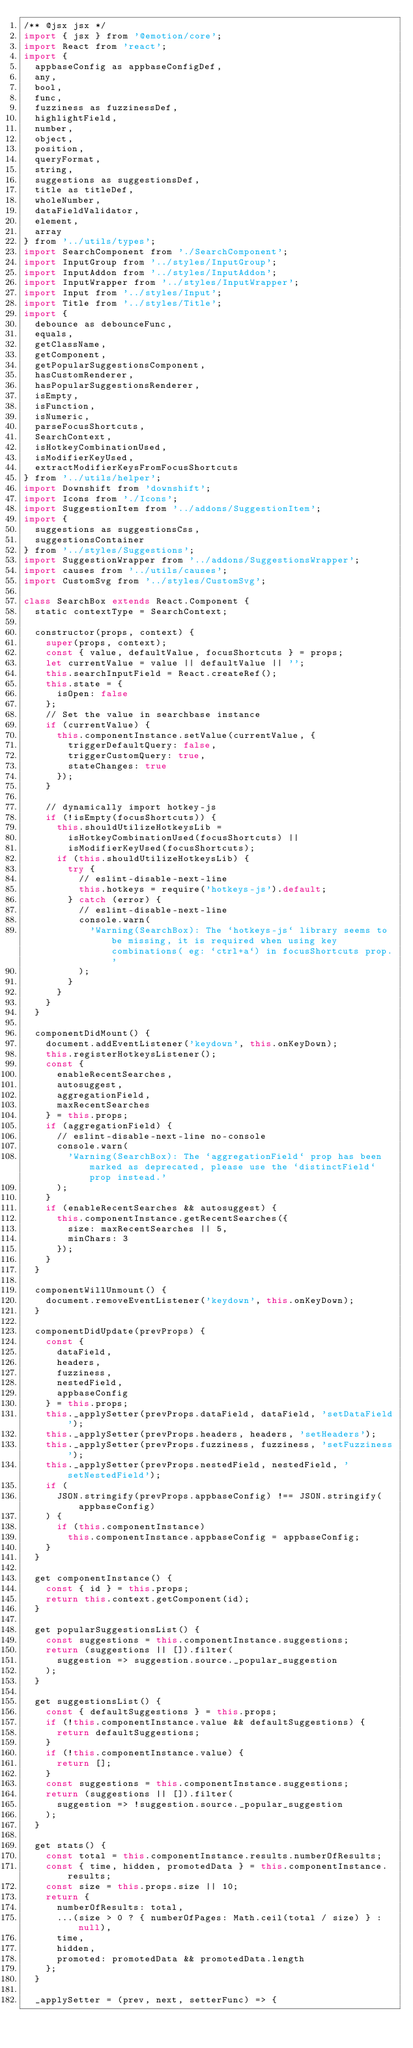<code> <loc_0><loc_0><loc_500><loc_500><_JavaScript_>/** @jsx jsx */
import { jsx } from '@emotion/core';
import React from 'react';
import {
  appbaseConfig as appbaseConfigDef,
  any,
  bool,
  func,
  fuzziness as fuzzinessDef,
  highlightField,
  number,
  object,
  position,
  queryFormat,
  string,
  suggestions as suggestionsDef,
  title as titleDef,
  wholeNumber,
  dataFieldValidator,
  element,
  array
} from '../utils/types';
import SearchComponent from './SearchComponent';
import InputGroup from '../styles/InputGroup';
import InputAddon from '../styles/InputAddon';
import InputWrapper from '../styles/InputWrapper';
import Input from '../styles/Input';
import Title from '../styles/Title';
import {
  debounce as debounceFunc,
  equals,
  getClassName,
  getComponent,
  getPopularSuggestionsComponent,
  hasCustomRenderer,
  hasPopularSuggestionsRenderer,
  isEmpty,
  isFunction,
  isNumeric,
  parseFocusShortcuts,
  SearchContext,
  isHotkeyCombinationUsed,
  isModifierKeyUsed,
  extractModifierKeysFromFocusShortcuts
} from '../utils/helper';
import Downshift from 'downshift';
import Icons from './Icons';
import SuggestionItem from '../addons/SuggestionItem';
import {
  suggestions as suggestionsCss,
  suggestionsContainer
} from '../styles/Suggestions';
import SuggestionWrapper from '../addons/SuggestionsWrapper';
import causes from '../utils/causes';
import CustomSvg from '../styles/CustomSvg';

class SearchBox extends React.Component {
  static contextType = SearchContext;

  constructor(props, context) {
    super(props, context);
    const { value, defaultValue, focusShortcuts } = props;
    let currentValue = value || defaultValue || '';
    this.searchInputField = React.createRef();
    this.state = {
      isOpen: false
    };
    // Set the value in searchbase instance
    if (currentValue) {
      this.componentInstance.setValue(currentValue, {
        triggerDefaultQuery: false,
        triggerCustomQuery: true,
        stateChanges: true
      });
    }

    // dynamically import hotkey-js
    if (!isEmpty(focusShortcuts)) {
      this.shouldUtilizeHotkeysLib =
        isHotkeyCombinationUsed(focusShortcuts) ||
        isModifierKeyUsed(focusShortcuts);
      if (this.shouldUtilizeHotkeysLib) {
        try {
          // eslint-disable-next-line
          this.hotkeys = require('hotkeys-js').default;
        } catch (error) {
          // eslint-disable-next-line
          console.warn(
            'Warning(SearchBox): The `hotkeys-js` library seems to be missing, it is required when using key combinations( eg: `ctrl+a`) in focusShortcuts prop.'
          );
        }
      }
    }
  }

  componentDidMount() {
    document.addEventListener('keydown', this.onKeyDown);
    this.registerHotkeysListener();
    const {
      enableRecentSearches,
      autosuggest,
      aggregationField,
      maxRecentSearches
    } = this.props;
    if (aggregationField) {
      // eslint-disable-next-line no-console
      console.warn(
        'Warning(SearchBox): The `aggregationField` prop has been marked as deprecated, please use the `distinctField` prop instead.'
      );
    }
    if (enableRecentSearches && autosuggest) {
      this.componentInstance.getRecentSearches({
        size: maxRecentSearches || 5,
        minChars: 3
      });
    }
  }

  componentWillUnmount() {
    document.removeEventListener('keydown', this.onKeyDown);
  }

  componentDidUpdate(prevProps) {
    const {
      dataField,
      headers,
      fuzziness,
      nestedField,
      appbaseConfig
    } = this.props;
    this._applySetter(prevProps.dataField, dataField, 'setDataField');
    this._applySetter(prevProps.headers, headers, 'setHeaders');
    this._applySetter(prevProps.fuzziness, fuzziness, 'setFuzziness');
    this._applySetter(prevProps.nestedField, nestedField, 'setNestedField');
    if (
      JSON.stringify(prevProps.appbaseConfig) !== JSON.stringify(appbaseConfig)
    ) {
      if (this.componentInstance)
        this.componentInstance.appbaseConfig = appbaseConfig;
    }
  }

  get componentInstance() {
    const { id } = this.props;
    return this.context.getComponent(id);
  }

  get popularSuggestionsList() {
    const suggestions = this.componentInstance.suggestions;
    return (suggestions || []).filter(
      suggestion => suggestion.source._popular_suggestion
    );
  }

  get suggestionsList() {
    const { defaultSuggestions } = this.props;
    if (!this.componentInstance.value && defaultSuggestions) {
      return defaultSuggestions;
    }
    if (!this.componentInstance.value) {
      return [];
    }
    const suggestions = this.componentInstance.suggestions;
    return (suggestions || []).filter(
      suggestion => !suggestion.source._popular_suggestion
    );
  }

  get stats() {
    const total = this.componentInstance.results.numberOfResults;
    const { time, hidden, promotedData } = this.componentInstance.results;
    const size = this.props.size || 10;
    return {
      numberOfResults: total,
      ...(size > 0 ? { numberOfPages: Math.ceil(total / size) } : null),
      time,
      hidden,
      promoted: promotedData && promotedData.length
    };
  }

  _applySetter = (prev, next, setterFunc) => {</code> 